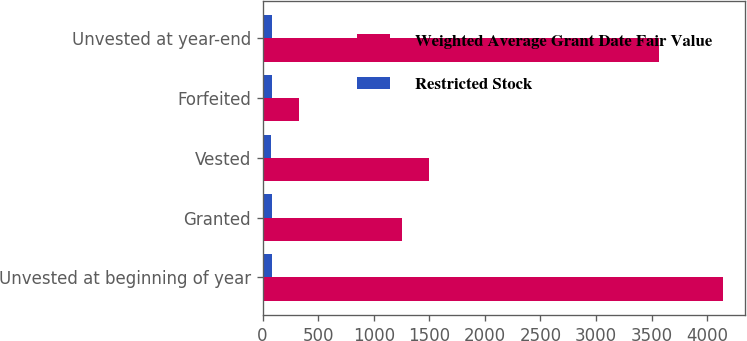<chart> <loc_0><loc_0><loc_500><loc_500><stacked_bar_chart><ecel><fcel>Unvested at beginning of year<fcel>Granted<fcel>Vested<fcel>Forfeited<fcel>Unvested at year-end<nl><fcel>Weighted Average Grant Date Fair Value<fcel>4138<fcel>1254<fcel>1495<fcel>326<fcel>3571<nl><fcel>Restricted Stock<fcel>80.8<fcel>82.37<fcel>71.3<fcel>83.86<fcel>85.04<nl></chart> 